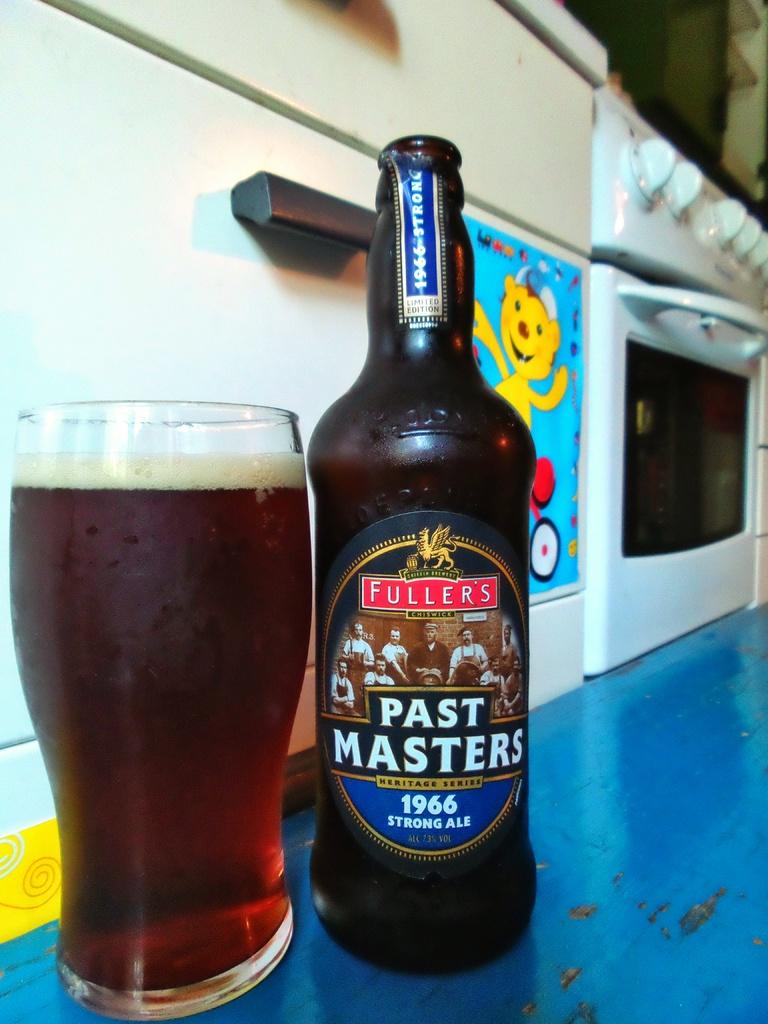What is the brand of this beer?
Offer a terse response. Fuller's. What year is the beer from?
Offer a terse response. 1966. 